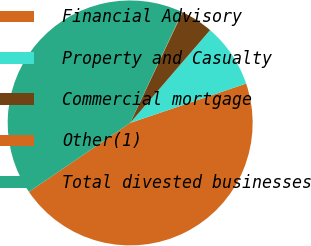<chart> <loc_0><loc_0><loc_500><loc_500><pie_chart><fcel>Financial Advisory<fcel>Property and Casualty<fcel>Commercial mortgage<fcel>Other(1)<fcel>Total divested businesses<nl><fcel>45.7%<fcel>8.48%<fcel>4.27%<fcel>0.06%<fcel>41.49%<nl></chart> 